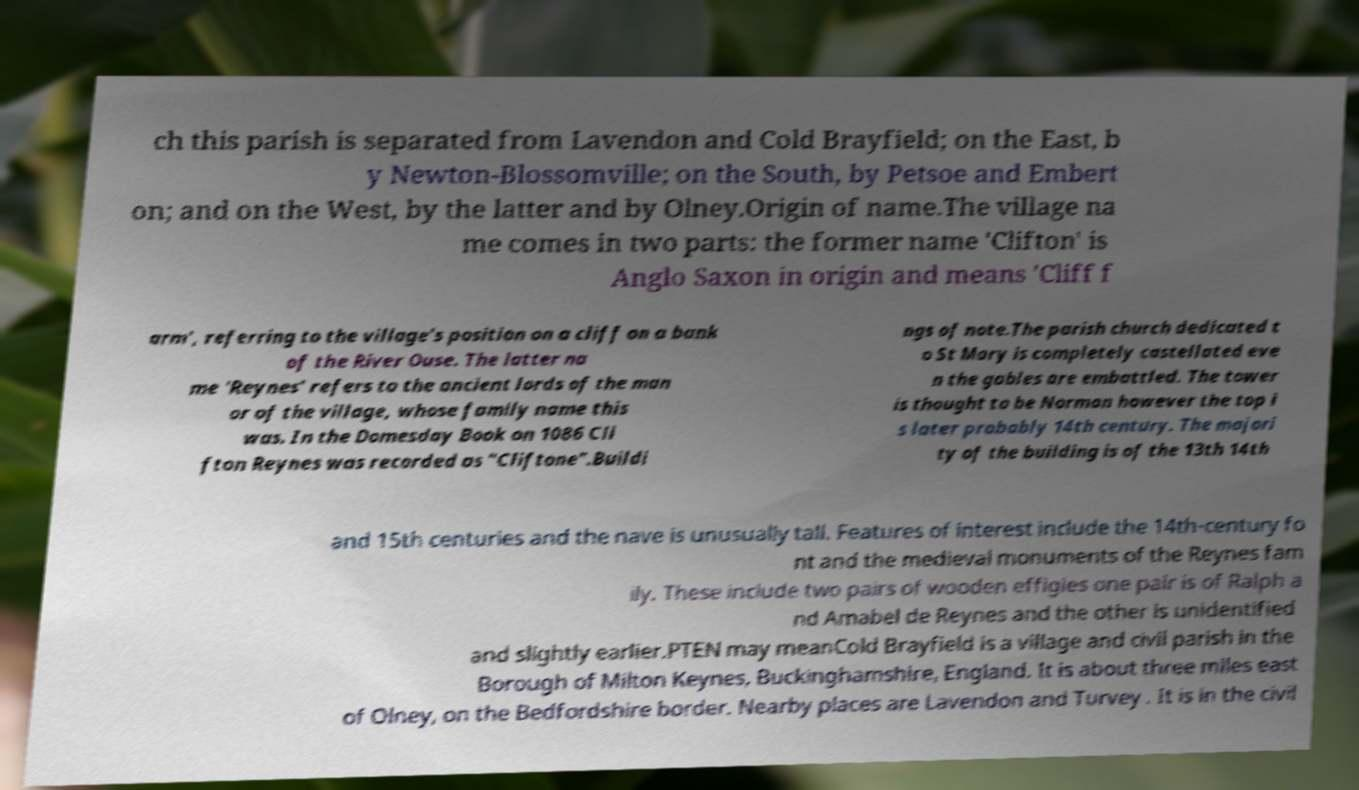For documentation purposes, I need the text within this image transcribed. Could you provide that? ch this parish is separated from Lavendon and Cold Brayfield; on the East, b y Newton-Blossomville; on the South, by Petsoe and Embert on; and on the West, by the latter and by Olney.Origin of name.The village na me comes in two parts: the former name 'Clifton' is Anglo Saxon in origin and means 'Cliff f arm', referring to the village's position on a cliff on a bank of the River Ouse. The latter na me 'Reynes' refers to the ancient lords of the man or of the village, whose family name this was. In the Domesday Book on 1086 Cli fton Reynes was recorded as "Cliftone".Buildi ngs of note.The parish church dedicated t o St Mary is completely castellated eve n the gables are embattled. The tower is thought to be Norman however the top i s later probably 14th century. The majori ty of the building is of the 13th 14th and 15th centuries and the nave is unusually tall. Features of interest include the 14th-century fo nt and the medieval monuments of the Reynes fam ily. These include two pairs of wooden effigies one pair is of Ralph a nd Amabel de Reynes and the other is unidentified and slightly earlier.PTEN may meanCold Brayfield is a village and civil parish in the Borough of Milton Keynes, Buckinghamshire, England. It is about three miles east of Olney, on the Bedfordshire border. Nearby places are Lavendon and Turvey . It is in the civil 